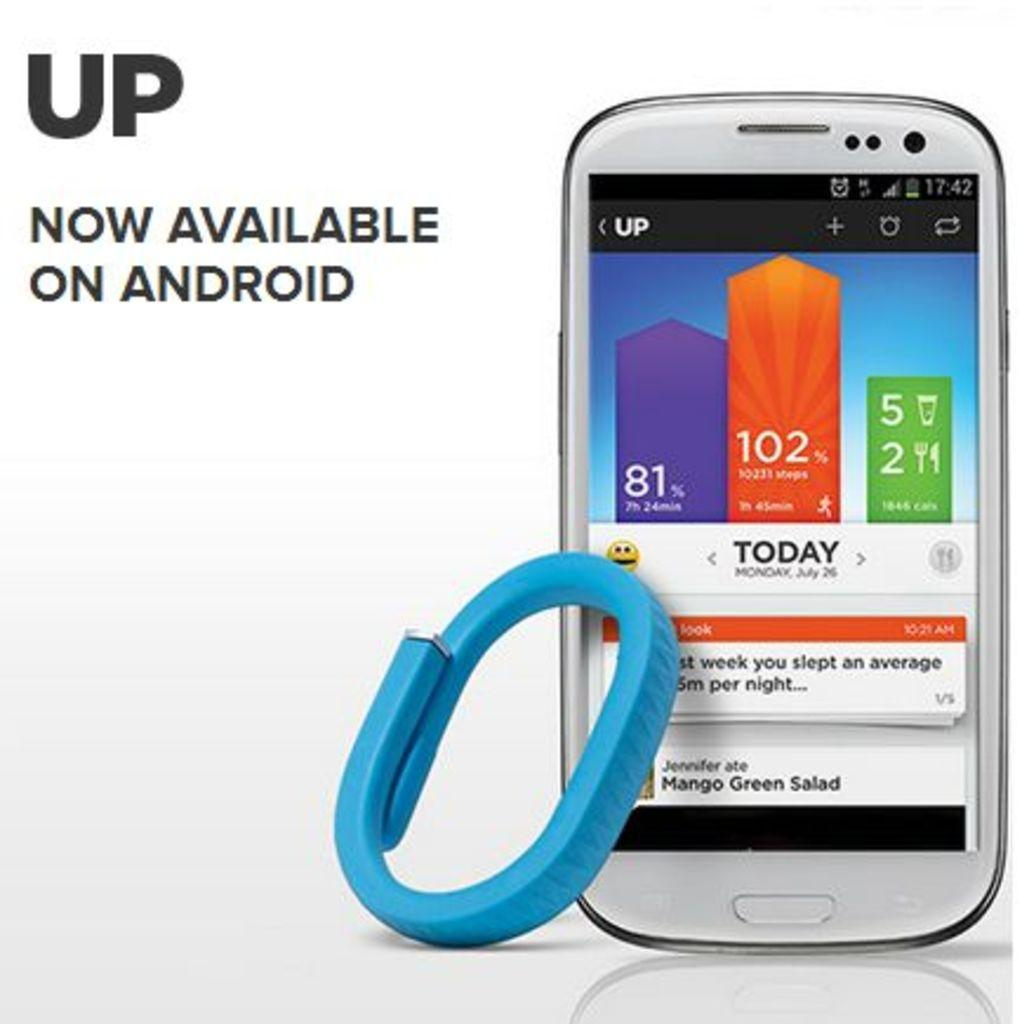<image>
Give a short and clear explanation of the subsequent image. A phone screen is displaying the UP app and has the word Today on it. 